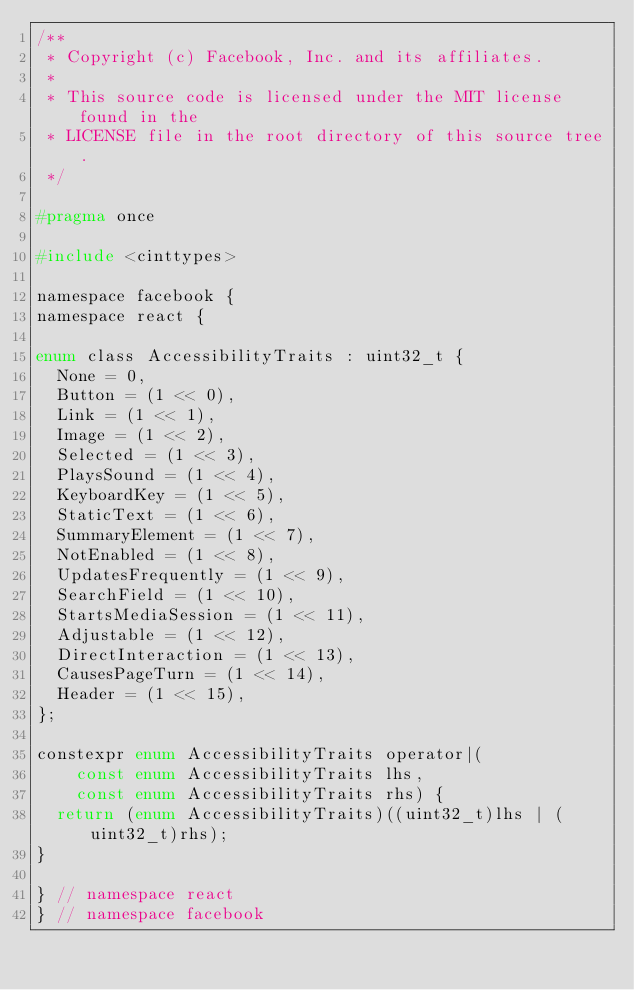<code> <loc_0><loc_0><loc_500><loc_500><_C_>/**
 * Copyright (c) Facebook, Inc. and its affiliates.
 *
 * This source code is licensed under the MIT license found in the
 * LICENSE file in the root directory of this source tree.
 */

#pragma once

#include <cinttypes>

namespace facebook {
namespace react {

enum class AccessibilityTraits : uint32_t {
  None = 0,
  Button = (1 << 0),
  Link = (1 << 1),
  Image = (1 << 2),
  Selected = (1 << 3),
  PlaysSound = (1 << 4),
  KeyboardKey = (1 << 5),
  StaticText = (1 << 6),
  SummaryElement = (1 << 7),
  NotEnabled = (1 << 8),
  UpdatesFrequently = (1 << 9),
  SearchField = (1 << 10),
  StartsMediaSession = (1 << 11),
  Adjustable = (1 << 12),
  DirectInteraction = (1 << 13),
  CausesPageTurn = (1 << 14),
  Header = (1 << 15),
};

constexpr enum AccessibilityTraits operator|(
    const enum AccessibilityTraits lhs,
    const enum AccessibilityTraits rhs) {
  return (enum AccessibilityTraits)((uint32_t)lhs | (uint32_t)rhs);
}

} // namespace react
} // namespace facebook
</code> 